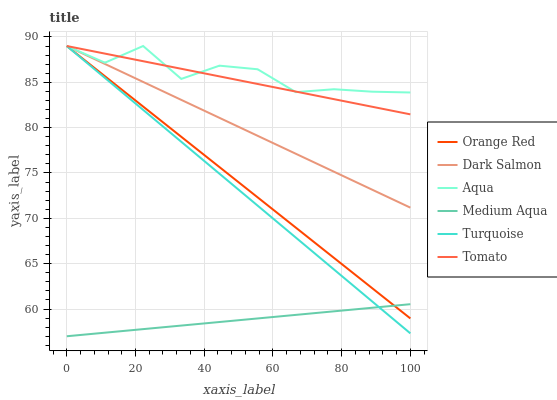Does Medium Aqua have the minimum area under the curve?
Answer yes or no. Yes. Does Aqua have the maximum area under the curve?
Answer yes or no. Yes. Does Turquoise have the minimum area under the curve?
Answer yes or no. No. Does Turquoise have the maximum area under the curve?
Answer yes or no. No. Is Medium Aqua the smoothest?
Answer yes or no. Yes. Is Aqua the roughest?
Answer yes or no. Yes. Is Turquoise the smoothest?
Answer yes or no. No. Is Turquoise the roughest?
Answer yes or no. No. Does Medium Aqua have the lowest value?
Answer yes or no. Yes. Does Turquoise have the lowest value?
Answer yes or no. No. Does Orange Red have the highest value?
Answer yes or no. Yes. Does Medium Aqua have the highest value?
Answer yes or no. No. Is Medium Aqua less than Aqua?
Answer yes or no. Yes. Is Dark Salmon greater than Medium Aqua?
Answer yes or no. Yes. Does Turquoise intersect Medium Aqua?
Answer yes or no. Yes. Is Turquoise less than Medium Aqua?
Answer yes or no. No. Is Turquoise greater than Medium Aqua?
Answer yes or no. No. Does Medium Aqua intersect Aqua?
Answer yes or no. No. 